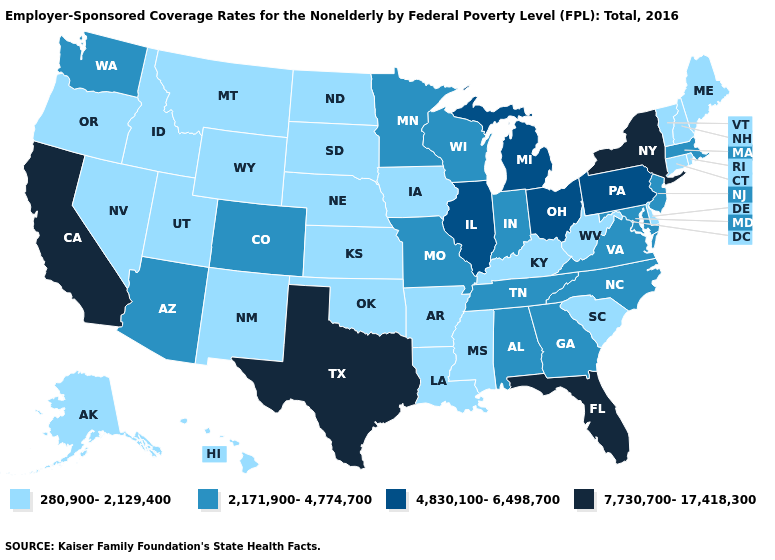Which states have the lowest value in the USA?
Concise answer only. Alaska, Arkansas, Connecticut, Delaware, Hawaii, Idaho, Iowa, Kansas, Kentucky, Louisiana, Maine, Mississippi, Montana, Nebraska, Nevada, New Hampshire, New Mexico, North Dakota, Oklahoma, Oregon, Rhode Island, South Carolina, South Dakota, Utah, Vermont, West Virginia, Wyoming. What is the value of Wisconsin?
Answer briefly. 2,171,900-4,774,700. What is the value of Maine?
Write a very short answer. 280,900-2,129,400. Among the states that border Arizona , which have the lowest value?
Quick response, please. Nevada, New Mexico, Utah. Name the states that have a value in the range 7,730,700-17,418,300?
Short answer required. California, Florida, New York, Texas. Does Nevada have a lower value than Minnesota?
Be succinct. Yes. What is the highest value in the South ?
Concise answer only. 7,730,700-17,418,300. Name the states that have a value in the range 4,830,100-6,498,700?
Answer briefly. Illinois, Michigan, Ohio, Pennsylvania. Among the states that border Idaho , does Nevada have the highest value?
Quick response, please. No. What is the value of Oregon?
Keep it brief. 280,900-2,129,400. What is the highest value in states that border California?
Write a very short answer. 2,171,900-4,774,700. Is the legend a continuous bar?
Quick response, please. No. Name the states that have a value in the range 280,900-2,129,400?
Answer briefly. Alaska, Arkansas, Connecticut, Delaware, Hawaii, Idaho, Iowa, Kansas, Kentucky, Louisiana, Maine, Mississippi, Montana, Nebraska, Nevada, New Hampshire, New Mexico, North Dakota, Oklahoma, Oregon, Rhode Island, South Carolina, South Dakota, Utah, Vermont, West Virginia, Wyoming. Does the first symbol in the legend represent the smallest category?
Quick response, please. Yes. Which states have the lowest value in the South?
Answer briefly. Arkansas, Delaware, Kentucky, Louisiana, Mississippi, Oklahoma, South Carolina, West Virginia. 